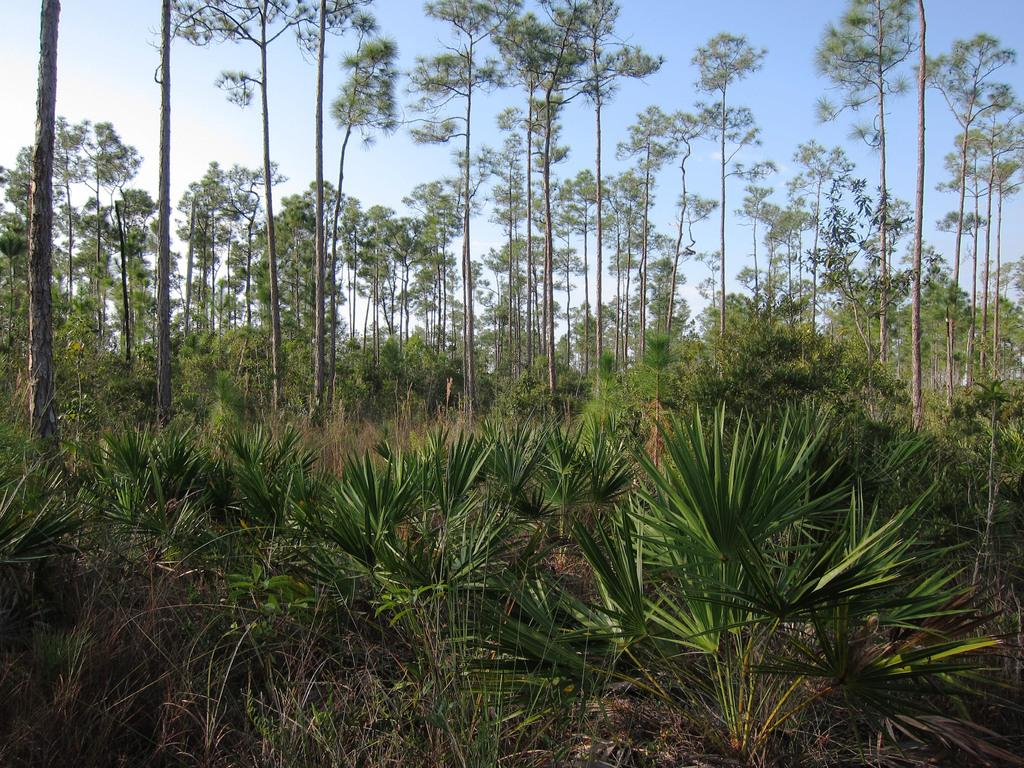What type of vegetation can be seen in the image? There are plants and trees in the image. Can you describe the background of the image? The sky is visible behind the trees in the image. How does the addition of a twist affect the plants in the image? There is no mention of an addition or twist in the image, so it cannot be determined how it would affect the plants. 